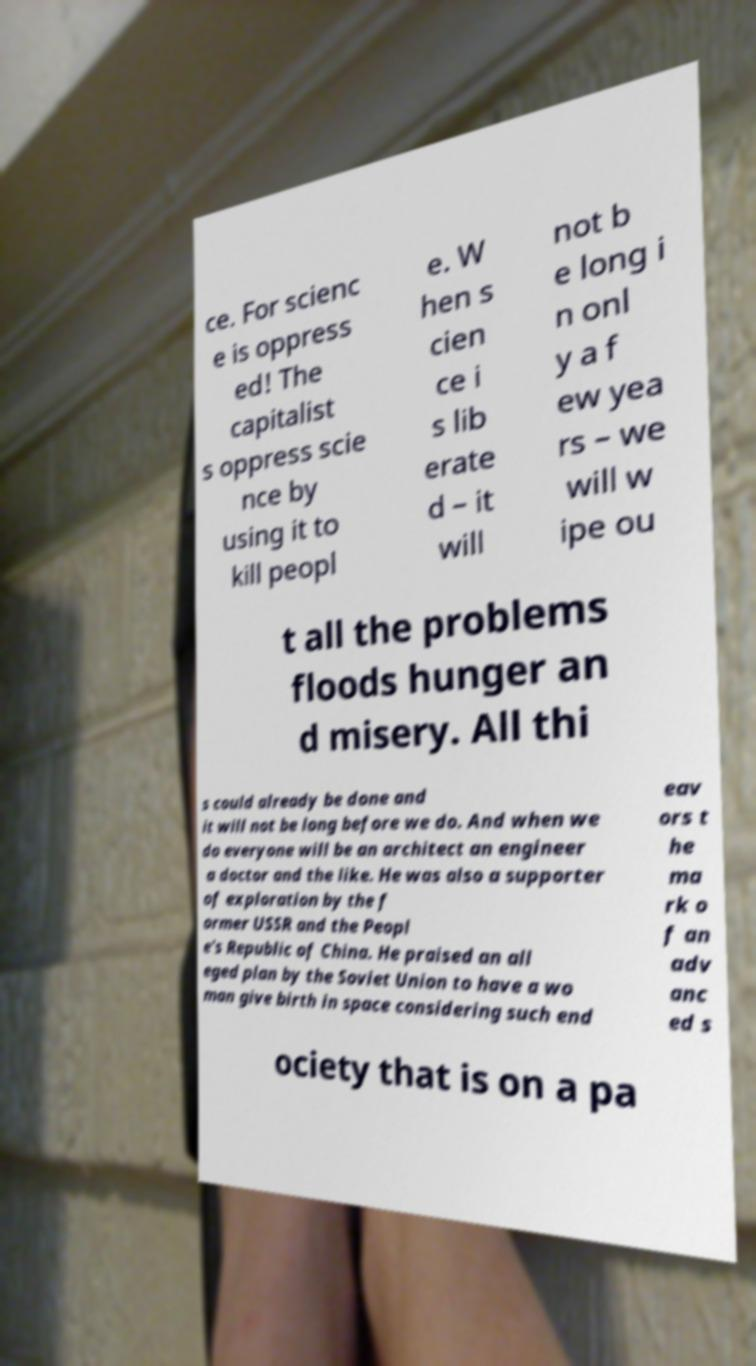Could you extract and type out the text from this image? ce. For scienc e is oppress ed! The capitalist s oppress scie nce by using it to kill peopl e. W hen s cien ce i s lib erate d – it will not b e long i n onl y a f ew yea rs – we will w ipe ou t all the problems floods hunger an d misery. All thi s could already be done and it will not be long before we do. And when we do everyone will be an architect an engineer a doctor and the like. He was also a supporter of exploration by the f ormer USSR and the Peopl e's Republic of China. He praised an all eged plan by the Soviet Union to have a wo man give birth in space considering such end eav ors t he ma rk o f an adv anc ed s ociety that is on a pa 